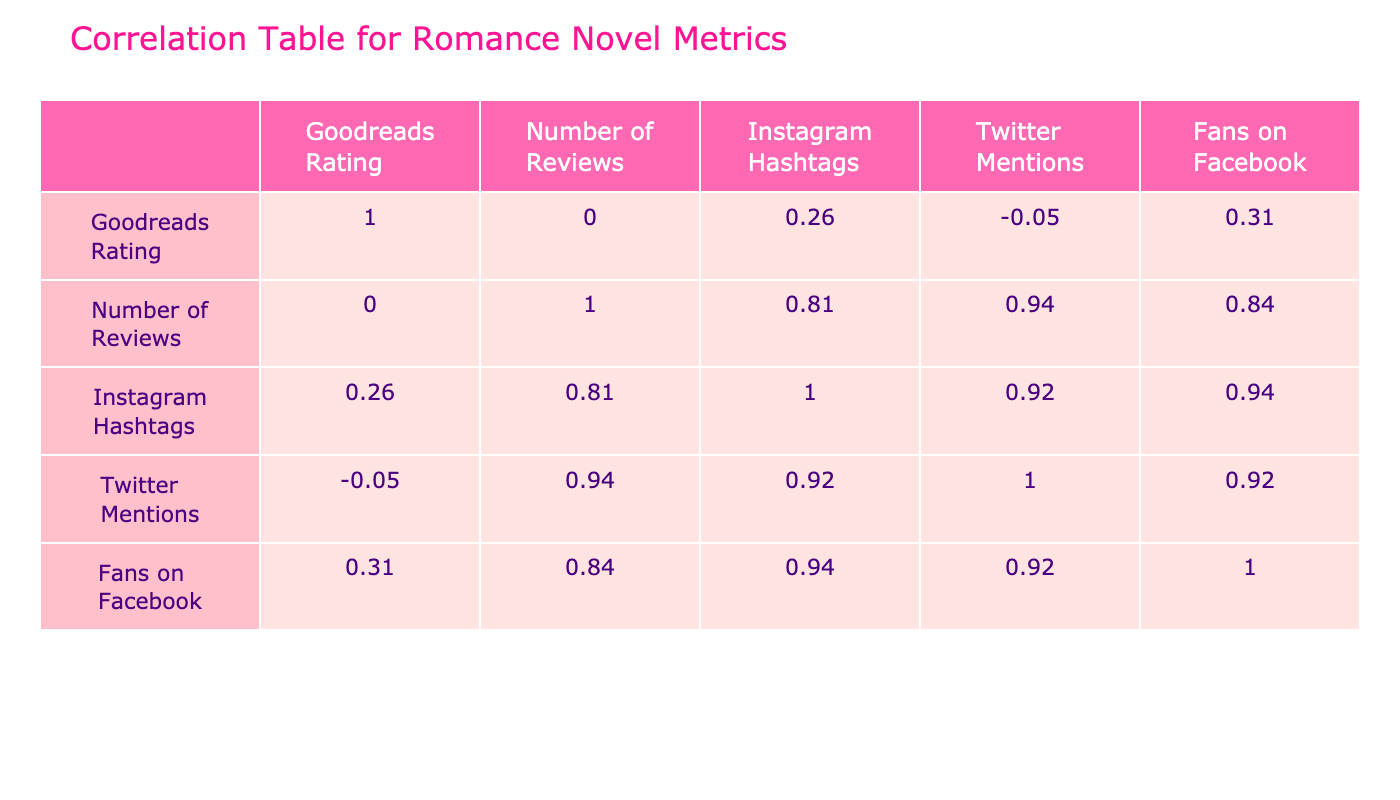What is the highest Goodreads rating among the books? Looking at the "Goodreads Rating" column, "It Ends with Us" has the highest score of 4.34.
Answer: 4.34 How many total reviews do the books have? The total reviews can be found by summing the "Number of Reviews" column: 12000 + 9500 + 70000 + 20000 + 30000 + 85000 + 30000 = 245500.
Answer: 245500 Is "Beautiful Disaster" mentioned more frequently on Twitter than "The Love Hypothesis"? By comparing the "Twitter Mentions," "Beautiful Disaster" has 9000 mentions while "The Love Hypothesis" has 2300 mentions, which confirms that "Beautiful Disaster" is mentioned more.
Answer: Yes Which book has the most Instagram hashtags related to it? By examining the "Instagram Hashtags" column, "It Ends with Us" has 25000 hashtags, more than any other book.
Answer: It Ends with Us What is the correlation between Goodreads rating and Facebook fans? To determine this, you would need to look at the correlation value in the table. By observing, there is a strong positive correlation, which indicates that books with higher ratings tend to have more Facebook fans.
Answer: Strong positive correlation Does any book have more Twitter mentions than Instagram hashtags? Comparing the columns, "Beautiful Disaster" with 9000 Twitter mentions has 18000 Instagram hashtags, indicating it does not. Similarly, "The Love Hypothesis" has 2300 Twitter mentions and 5000 Instagram hashtags, also not fitting the criteria. In each case, no book fulfills this condition.
Answer: No What is the average number of Instagram hashtags across all books? To find this, sum all Instagram hashtags: (5000 + 4000 + 25000 + 15000 + 12000 + 18000 + 7000) = 68000. Then divide by the number of books, which is 7: 68000 / 7 = approximately 9714.
Answer: Approximately 9714 Which author has the book with the highest number of reviews, and how many reviews does it have? "Beautiful Disaster" by Jamie McGuire has the highest number of reviews at 85000, making it the author's highlighted book in this respect.
Answer: Jamie McGuire, 85000 